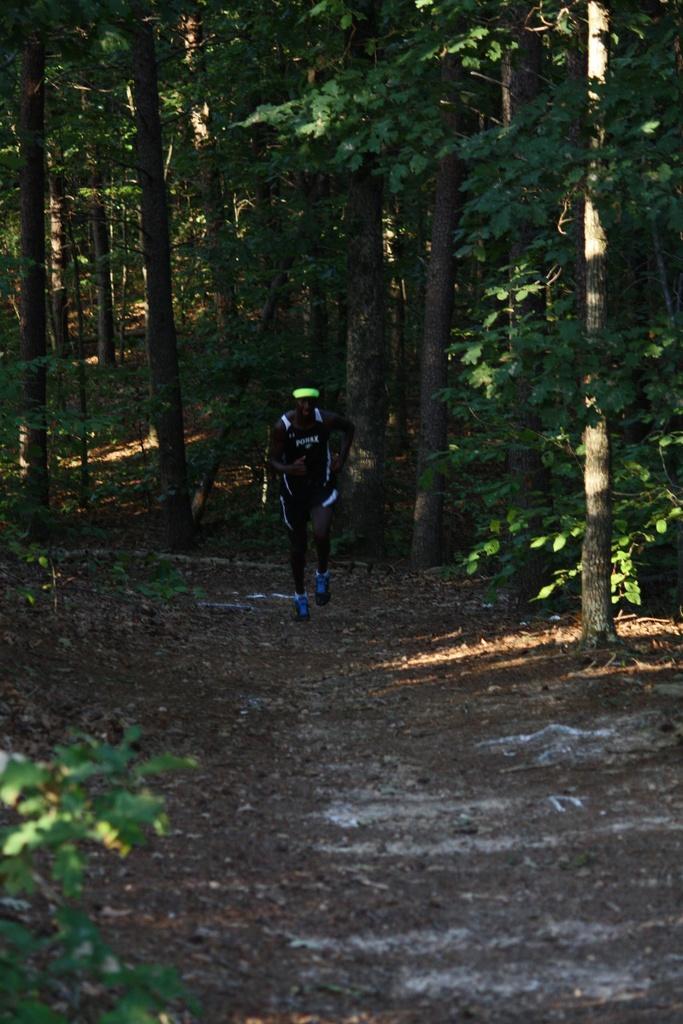How would you summarize this image in a sentence or two? In this image there is an athlete running, behind the athlete there are trees. 